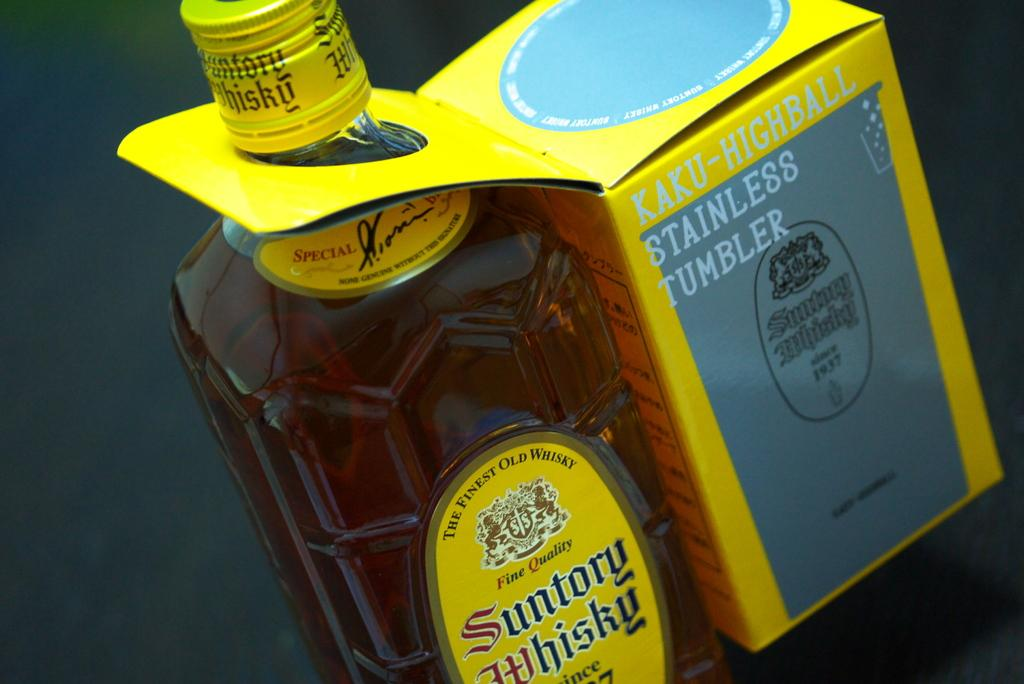<image>
Render a clear and concise summary of the photo. A bottle of whiskey with a stainless steel tumbler attached as an extra. 